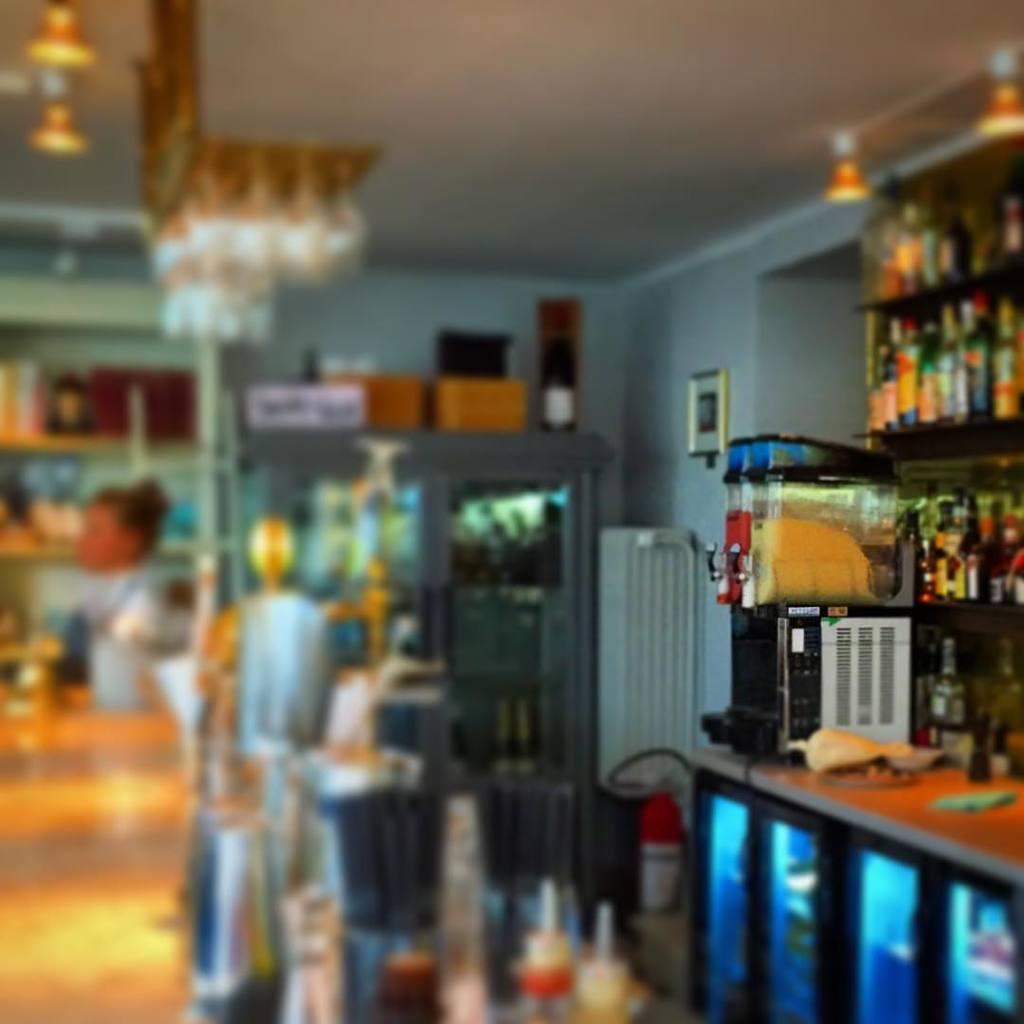In one or two sentences, can you explain what this image depicts? In this picture I can see on the left side there is a woman, in the middle it looks like a refrigerator, on the right side there is a machine and there are bottles on the shelves. At the top there are lights. 